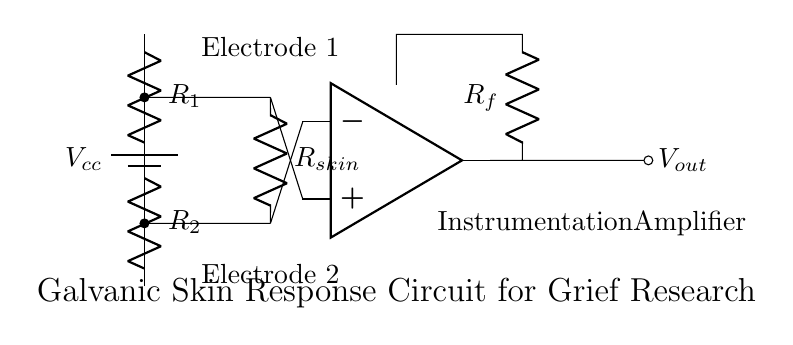What is the power supply in this circuit? The circuit has a power supply labeled as Vcc, which indicates it provides the necessary voltage for the operation of the components.
Answer: Vcc What components make up the voltage divider? The voltage divider in this circuit consists of two resistors, labeled R1 and R2. They are connected in series to divide the applied voltage.
Answer: R1 and R2 What type of amplifier is used in this circuit? The circuit includes an operational amplifier, indicated by the symbol specific to such devices. It is responsible for amplifying the voltage difference.
Answer: Operational amplifier How does the skin resistance affect the output signal? The skin resistance, denoted as Rskin, varies with the changes in stress levels. This variation impacts the voltage difference seen by the operational amplifier, thus affecting the output signal.
Answer: It affects the output signal What does the output voltage signify in this circuit? The output voltage, represented as Vout, reflects the amplified response based on the changes in skin resistance due to stress levels associated with complicated grief.
Answer: Amplified response to stress 